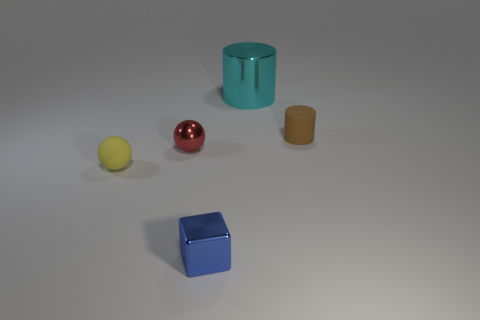Given the shadowing, what can you infer about the light source in this setting? The shadows cast in the image indicate that the light source is coming from the upper left side, as evidenced by the direction and placement of the shadows relative to the objects. The shadows are softly blurred, implying that the light source is diffused rather than point-like, providing a uniform illumination. 